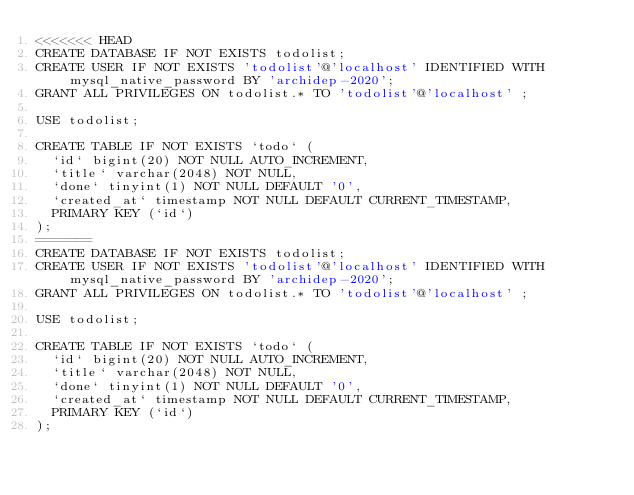Convert code to text. <code><loc_0><loc_0><loc_500><loc_500><_SQL_><<<<<<< HEAD
CREATE DATABASE IF NOT EXISTS todolist;
CREATE USER IF NOT EXISTS 'todolist'@'localhost' IDENTIFIED WITH mysql_native_password BY 'archidep-2020';
GRANT ALL PRIVILEGES ON todolist.* TO 'todolist'@'localhost' ;

USE todolist;

CREATE TABLE IF NOT EXISTS `todo` (
  `id` bigint(20) NOT NULL AUTO_INCREMENT,
  `title` varchar(2048) NOT NULL,
  `done` tinyint(1) NOT NULL DEFAULT '0',
  `created_at` timestamp NOT NULL DEFAULT CURRENT_TIMESTAMP,
  PRIMARY KEY (`id`)
);
=======
CREATE DATABASE IF NOT EXISTS todolist;
CREATE USER IF NOT EXISTS 'todolist'@'localhost' IDENTIFIED WITH mysql_native_password BY 'archidep-2020';
GRANT ALL PRIVILEGES ON todolist.* TO 'todolist'@'localhost' ;

USE todolist;

CREATE TABLE IF NOT EXISTS `todo` (
  `id` bigint(20) NOT NULL AUTO_INCREMENT,
  `title` varchar(2048) NOT NULL,
  `done` tinyint(1) NOT NULL DEFAULT '0',
  `created_at` timestamp NOT NULL DEFAULT CURRENT_TIMESTAMP,
  PRIMARY KEY (`id`)
);</code> 